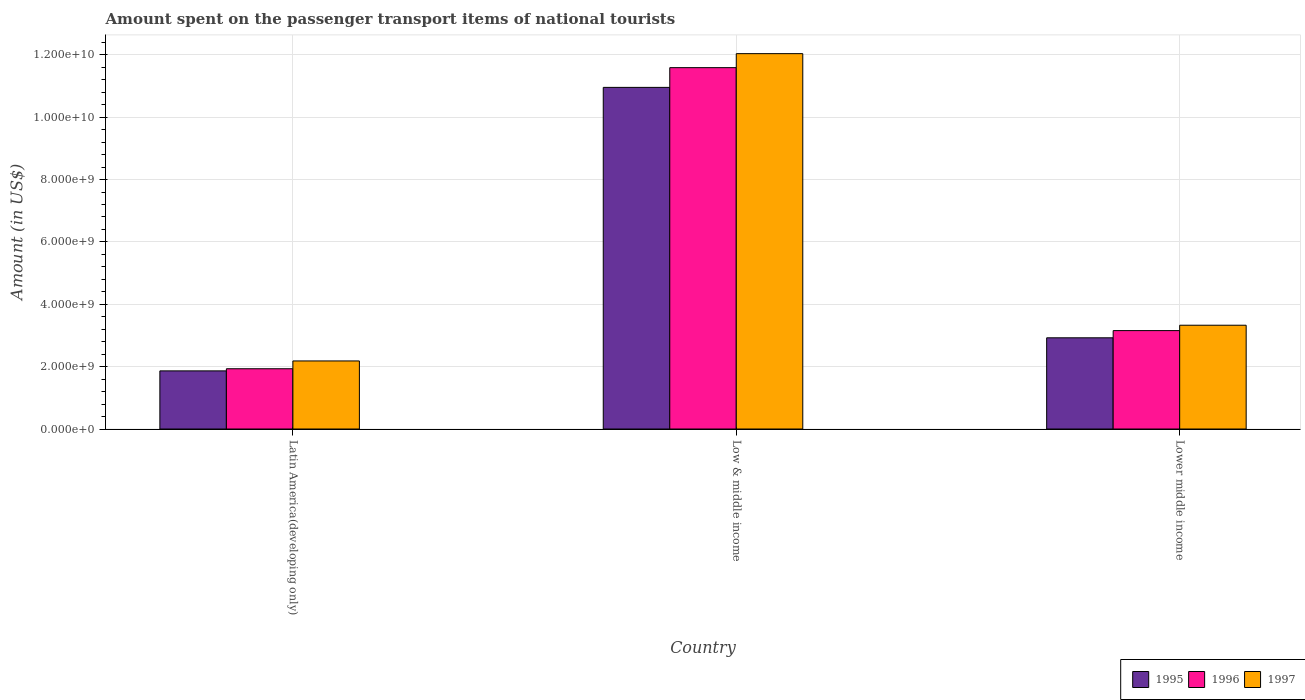How many groups of bars are there?
Offer a terse response. 3. How many bars are there on the 1st tick from the left?
Provide a short and direct response. 3. What is the label of the 3rd group of bars from the left?
Keep it short and to the point. Lower middle income. What is the amount spent on the passenger transport items of national tourists in 1995 in Latin America(developing only)?
Your response must be concise. 1.86e+09. Across all countries, what is the maximum amount spent on the passenger transport items of national tourists in 1995?
Your response must be concise. 1.10e+1. Across all countries, what is the minimum amount spent on the passenger transport items of national tourists in 1995?
Ensure brevity in your answer.  1.86e+09. In which country was the amount spent on the passenger transport items of national tourists in 1995 maximum?
Make the answer very short. Low & middle income. In which country was the amount spent on the passenger transport items of national tourists in 1997 minimum?
Ensure brevity in your answer.  Latin America(developing only). What is the total amount spent on the passenger transport items of national tourists in 1997 in the graph?
Keep it short and to the point. 1.75e+1. What is the difference between the amount spent on the passenger transport items of national tourists in 1995 in Latin America(developing only) and that in Lower middle income?
Keep it short and to the point. -1.06e+09. What is the difference between the amount spent on the passenger transport items of national tourists in 1997 in Lower middle income and the amount spent on the passenger transport items of national tourists in 1995 in Latin America(developing only)?
Make the answer very short. 1.46e+09. What is the average amount spent on the passenger transport items of national tourists in 1995 per country?
Ensure brevity in your answer.  5.25e+09. What is the difference between the amount spent on the passenger transport items of national tourists of/in 1995 and amount spent on the passenger transport items of national tourists of/in 1996 in Lower middle income?
Make the answer very short. -2.31e+08. What is the ratio of the amount spent on the passenger transport items of national tourists in 1995 in Latin America(developing only) to that in Lower middle income?
Your answer should be compact. 0.64. What is the difference between the highest and the second highest amount spent on the passenger transport items of national tourists in 1995?
Give a very brief answer. -9.09e+09. What is the difference between the highest and the lowest amount spent on the passenger transport items of national tourists in 1997?
Ensure brevity in your answer.  9.85e+09. In how many countries, is the amount spent on the passenger transport items of national tourists in 1997 greater than the average amount spent on the passenger transport items of national tourists in 1997 taken over all countries?
Provide a succinct answer. 1. Is the sum of the amount spent on the passenger transport items of national tourists in 1996 in Latin America(developing only) and Low & middle income greater than the maximum amount spent on the passenger transport items of national tourists in 1995 across all countries?
Your answer should be very brief. Yes. What does the 3rd bar from the left in Low & middle income represents?
Ensure brevity in your answer.  1997. What does the 2nd bar from the right in Lower middle income represents?
Your answer should be compact. 1996. How many bars are there?
Keep it short and to the point. 9. Are all the bars in the graph horizontal?
Give a very brief answer. No. How many countries are there in the graph?
Give a very brief answer. 3. What is the difference between two consecutive major ticks on the Y-axis?
Your response must be concise. 2.00e+09. Does the graph contain grids?
Provide a succinct answer. Yes. Where does the legend appear in the graph?
Ensure brevity in your answer.  Bottom right. How are the legend labels stacked?
Ensure brevity in your answer.  Horizontal. What is the title of the graph?
Your answer should be very brief. Amount spent on the passenger transport items of national tourists. Does "2011" appear as one of the legend labels in the graph?
Your answer should be very brief. No. What is the Amount (in US$) in 1995 in Latin America(developing only)?
Offer a very short reply. 1.86e+09. What is the Amount (in US$) in 1996 in Latin America(developing only)?
Make the answer very short. 1.93e+09. What is the Amount (in US$) in 1997 in Latin America(developing only)?
Your answer should be very brief. 2.18e+09. What is the Amount (in US$) in 1995 in Low & middle income?
Keep it short and to the point. 1.10e+1. What is the Amount (in US$) of 1996 in Low & middle income?
Your answer should be very brief. 1.16e+1. What is the Amount (in US$) of 1997 in Low & middle income?
Your response must be concise. 1.20e+1. What is the Amount (in US$) of 1995 in Lower middle income?
Provide a succinct answer. 2.92e+09. What is the Amount (in US$) in 1996 in Lower middle income?
Provide a succinct answer. 3.16e+09. What is the Amount (in US$) of 1997 in Lower middle income?
Ensure brevity in your answer.  3.33e+09. Across all countries, what is the maximum Amount (in US$) in 1995?
Your answer should be very brief. 1.10e+1. Across all countries, what is the maximum Amount (in US$) of 1996?
Provide a succinct answer. 1.16e+1. Across all countries, what is the maximum Amount (in US$) of 1997?
Your response must be concise. 1.20e+1. Across all countries, what is the minimum Amount (in US$) of 1995?
Provide a short and direct response. 1.86e+09. Across all countries, what is the minimum Amount (in US$) of 1996?
Ensure brevity in your answer.  1.93e+09. Across all countries, what is the minimum Amount (in US$) in 1997?
Offer a terse response. 2.18e+09. What is the total Amount (in US$) of 1995 in the graph?
Keep it short and to the point. 1.57e+1. What is the total Amount (in US$) in 1996 in the graph?
Your answer should be very brief. 1.67e+1. What is the total Amount (in US$) of 1997 in the graph?
Your answer should be very brief. 1.75e+1. What is the difference between the Amount (in US$) in 1995 in Latin America(developing only) and that in Low & middle income?
Offer a very short reply. -9.09e+09. What is the difference between the Amount (in US$) of 1996 in Latin America(developing only) and that in Low & middle income?
Offer a very short reply. -9.65e+09. What is the difference between the Amount (in US$) of 1997 in Latin America(developing only) and that in Low & middle income?
Your response must be concise. -9.85e+09. What is the difference between the Amount (in US$) of 1995 in Latin America(developing only) and that in Lower middle income?
Provide a short and direct response. -1.06e+09. What is the difference between the Amount (in US$) of 1996 in Latin America(developing only) and that in Lower middle income?
Make the answer very short. -1.22e+09. What is the difference between the Amount (in US$) of 1997 in Latin America(developing only) and that in Lower middle income?
Offer a terse response. -1.15e+09. What is the difference between the Amount (in US$) in 1995 in Low & middle income and that in Lower middle income?
Offer a very short reply. 8.03e+09. What is the difference between the Amount (in US$) of 1996 in Low & middle income and that in Lower middle income?
Ensure brevity in your answer.  8.43e+09. What is the difference between the Amount (in US$) of 1997 in Low & middle income and that in Lower middle income?
Provide a short and direct response. 8.71e+09. What is the difference between the Amount (in US$) of 1995 in Latin America(developing only) and the Amount (in US$) of 1996 in Low & middle income?
Provide a short and direct response. -9.72e+09. What is the difference between the Amount (in US$) of 1995 in Latin America(developing only) and the Amount (in US$) of 1997 in Low & middle income?
Offer a terse response. -1.02e+1. What is the difference between the Amount (in US$) in 1996 in Latin America(developing only) and the Amount (in US$) in 1997 in Low & middle income?
Offer a terse response. -1.01e+1. What is the difference between the Amount (in US$) of 1995 in Latin America(developing only) and the Amount (in US$) of 1996 in Lower middle income?
Provide a succinct answer. -1.29e+09. What is the difference between the Amount (in US$) in 1995 in Latin America(developing only) and the Amount (in US$) in 1997 in Lower middle income?
Provide a succinct answer. -1.46e+09. What is the difference between the Amount (in US$) of 1996 in Latin America(developing only) and the Amount (in US$) of 1997 in Lower middle income?
Offer a terse response. -1.40e+09. What is the difference between the Amount (in US$) of 1995 in Low & middle income and the Amount (in US$) of 1996 in Lower middle income?
Offer a terse response. 7.80e+09. What is the difference between the Amount (in US$) of 1995 in Low & middle income and the Amount (in US$) of 1997 in Lower middle income?
Your response must be concise. 7.63e+09. What is the difference between the Amount (in US$) in 1996 in Low & middle income and the Amount (in US$) in 1997 in Lower middle income?
Your response must be concise. 8.26e+09. What is the average Amount (in US$) in 1995 per country?
Your response must be concise. 5.25e+09. What is the average Amount (in US$) in 1996 per country?
Your answer should be very brief. 5.56e+09. What is the average Amount (in US$) of 1997 per country?
Ensure brevity in your answer.  5.85e+09. What is the difference between the Amount (in US$) in 1995 and Amount (in US$) in 1996 in Latin America(developing only)?
Your answer should be very brief. -6.84e+07. What is the difference between the Amount (in US$) of 1995 and Amount (in US$) of 1997 in Latin America(developing only)?
Offer a very short reply. -3.19e+08. What is the difference between the Amount (in US$) of 1996 and Amount (in US$) of 1997 in Latin America(developing only)?
Your answer should be compact. -2.50e+08. What is the difference between the Amount (in US$) in 1995 and Amount (in US$) in 1996 in Low & middle income?
Give a very brief answer. -6.33e+08. What is the difference between the Amount (in US$) in 1995 and Amount (in US$) in 1997 in Low & middle income?
Your response must be concise. -1.08e+09. What is the difference between the Amount (in US$) of 1996 and Amount (in US$) of 1997 in Low & middle income?
Your answer should be very brief. -4.49e+08. What is the difference between the Amount (in US$) in 1995 and Amount (in US$) in 1996 in Lower middle income?
Keep it short and to the point. -2.31e+08. What is the difference between the Amount (in US$) in 1995 and Amount (in US$) in 1997 in Lower middle income?
Provide a succinct answer. -4.03e+08. What is the difference between the Amount (in US$) of 1996 and Amount (in US$) of 1997 in Lower middle income?
Give a very brief answer. -1.73e+08. What is the ratio of the Amount (in US$) of 1995 in Latin America(developing only) to that in Low & middle income?
Your answer should be compact. 0.17. What is the ratio of the Amount (in US$) in 1996 in Latin America(developing only) to that in Low & middle income?
Offer a very short reply. 0.17. What is the ratio of the Amount (in US$) of 1997 in Latin America(developing only) to that in Low & middle income?
Give a very brief answer. 0.18. What is the ratio of the Amount (in US$) in 1995 in Latin America(developing only) to that in Lower middle income?
Ensure brevity in your answer.  0.64. What is the ratio of the Amount (in US$) in 1996 in Latin America(developing only) to that in Lower middle income?
Keep it short and to the point. 0.61. What is the ratio of the Amount (in US$) in 1997 in Latin America(developing only) to that in Lower middle income?
Keep it short and to the point. 0.66. What is the ratio of the Amount (in US$) of 1995 in Low & middle income to that in Lower middle income?
Your answer should be very brief. 3.75. What is the ratio of the Amount (in US$) in 1996 in Low & middle income to that in Lower middle income?
Make the answer very short. 3.67. What is the ratio of the Amount (in US$) of 1997 in Low & middle income to that in Lower middle income?
Ensure brevity in your answer.  3.62. What is the difference between the highest and the second highest Amount (in US$) in 1995?
Offer a very short reply. 8.03e+09. What is the difference between the highest and the second highest Amount (in US$) in 1996?
Offer a very short reply. 8.43e+09. What is the difference between the highest and the second highest Amount (in US$) of 1997?
Make the answer very short. 8.71e+09. What is the difference between the highest and the lowest Amount (in US$) in 1995?
Offer a terse response. 9.09e+09. What is the difference between the highest and the lowest Amount (in US$) in 1996?
Keep it short and to the point. 9.65e+09. What is the difference between the highest and the lowest Amount (in US$) of 1997?
Keep it short and to the point. 9.85e+09. 